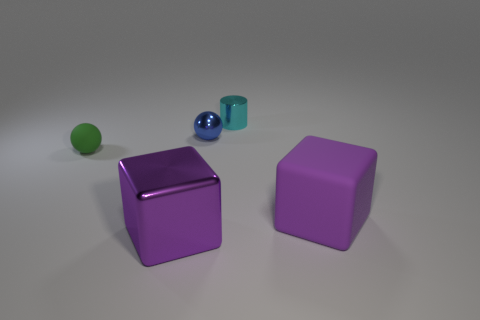Subtract 1 spheres. How many spheres are left? 1 Add 4 rubber cubes. How many objects exist? 9 Subtract all green cylinders. Subtract all purple cubes. How many cylinders are left? 1 Subtract all cylinders. How many objects are left? 4 Subtract all red cylinders. How many gray blocks are left? 0 Subtract all metallic cubes. Subtract all cyan shiny cylinders. How many objects are left? 3 Add 3 purple shiny things. How many purple shiny things are left? 4 Add 1 small cylinders. How many small cylinders exist? 2 Subtract 1 green balls. How many objects are left? 4 